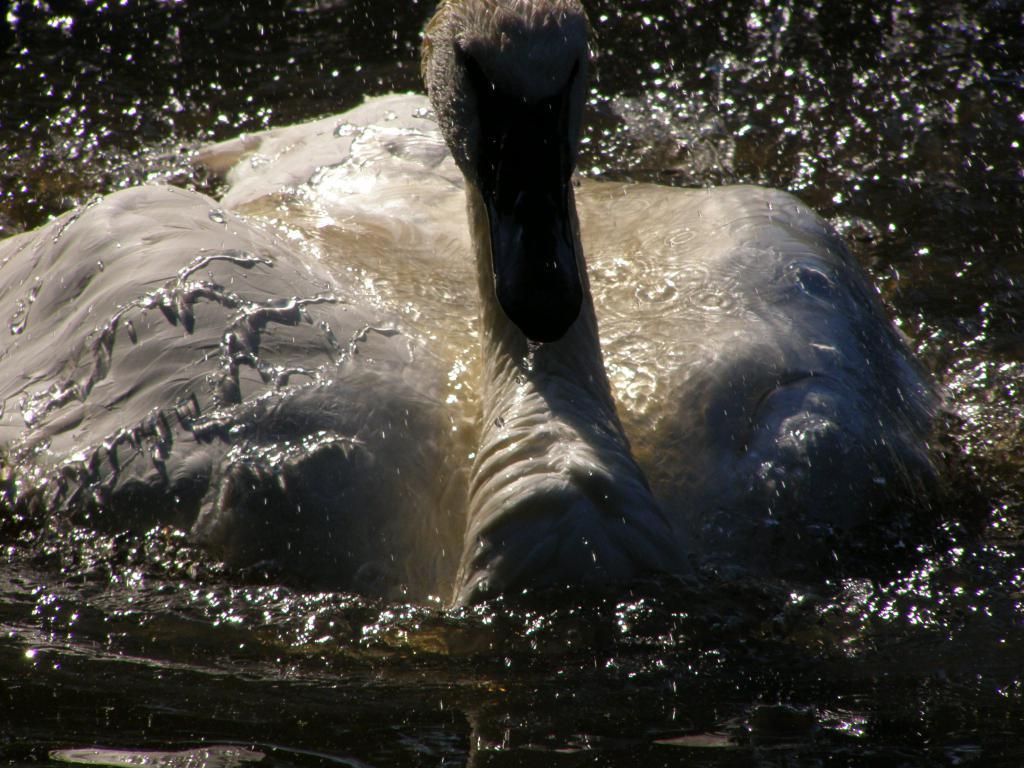Can you describe this image briefly? In this image I can see a swan and water. 